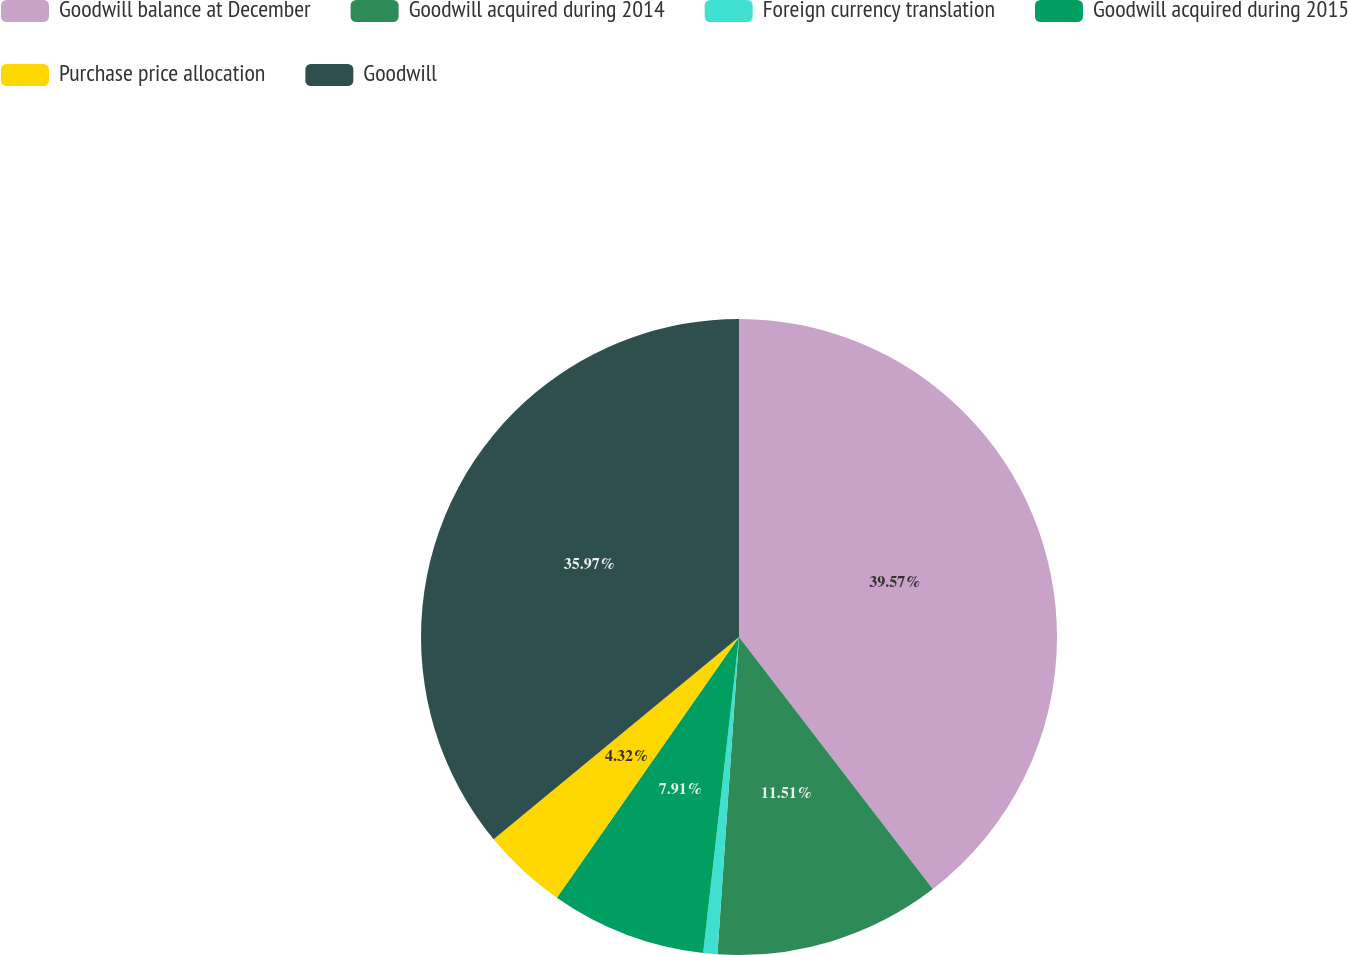Convert chart. <chart><loc_0><loc_0><loc_500><loc_500><pie_chart><fcel>Goodwill balance at December<fcel>Goodwill acquired during 2014<fcel>Foreign currency translation<fcel>Goodwill acquired during 2015<fcel>Purchase price allocation<fcel>Goodwill<nl><fcel>39.57%<fcel>11.51%<fcel>0.72%<fcel>7.91%<fcel>4.32%<fcel>35.97%<nl></chart> 